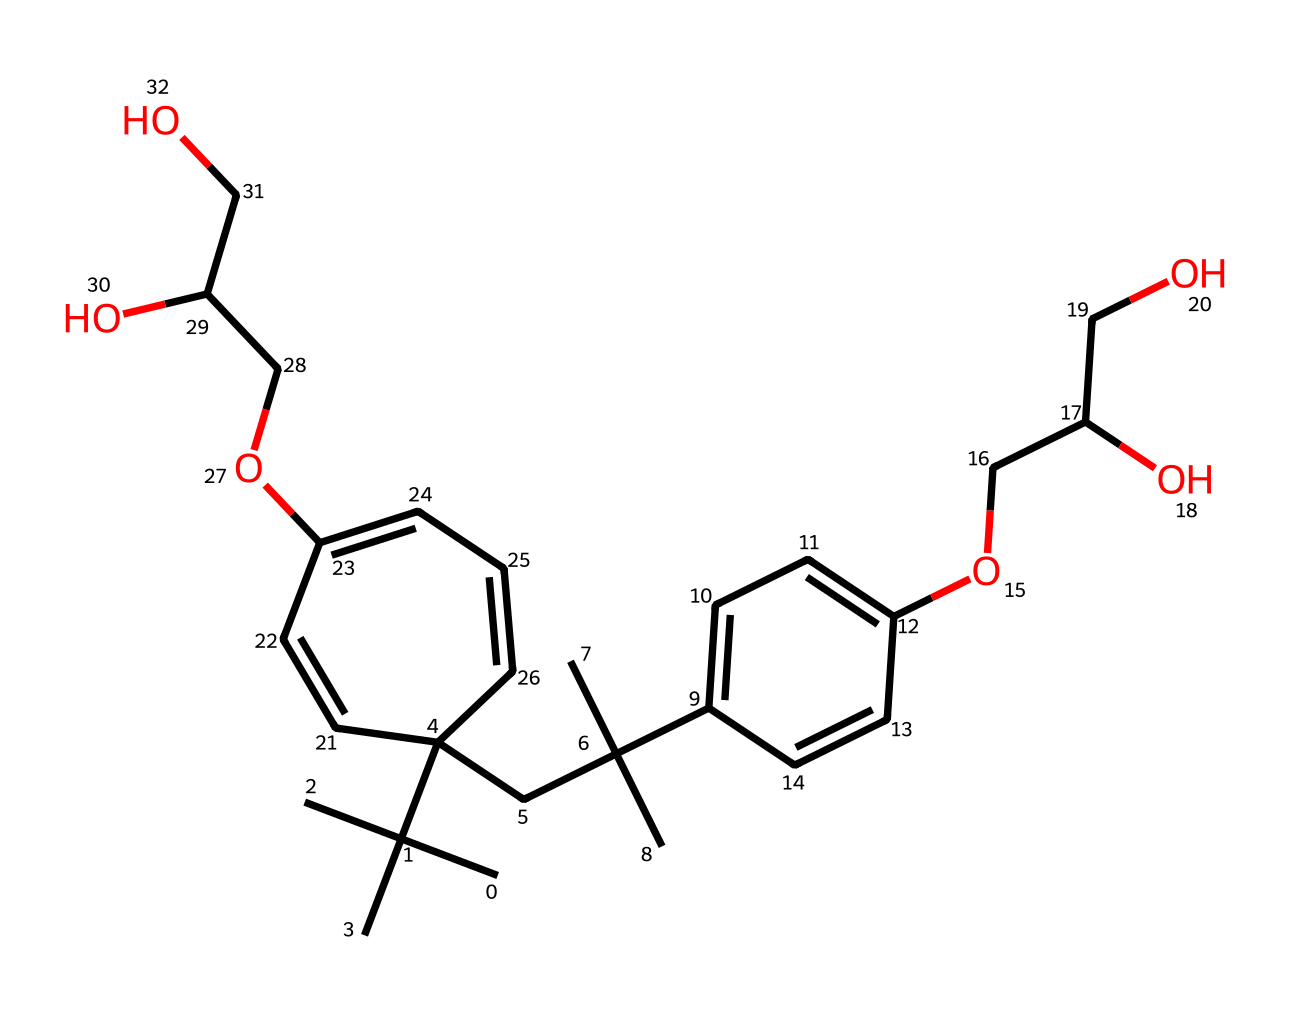What is the molecular formula of this compound? By analyzing the SMILES representation, we identify the carbon (C), hydrogen (H), and oxygen (O) atoms present. Counting the individual atoms gives us the formula C23H38O4.
Answer: C23H38O4 How many carbon atoms are present in the molecule? In the provided SMILES, we can see each ‘C’ represents a carbon atom. Counting the carbon atoms in the structure results in 23 carbons.
Answer: 23 What type of polymer is represented by this structure? The structure indicates that this compound is a type of silicone polymer due to the presence of repeat units connected by flexible links, characteristic of non-Newtonian fluids like silly putty.
Answer: silicone What properties of the molecule contribute to its non-Newtonian behavior? The molecular structure contains both flexible segments and rigid segments, allowing it to respond differently to stress; the soft segments flow under slow stress and the rigid segments maintain shape under rapid stress, typical in non-Newtonian fluids.
Answer: flexible and rigid Does this compound exhibit shear-thinning behavior? Yes, shear-thinning behavior is indicated if the chemical flows more easily under stress, which is a characteristic of the molecular interactions present in the structure.
Answer: yes What functional groups are present in this chemical? Upon examining the structure, we observe hydroxyl (-OH) groups, indicating the presence of alcohols which play a role in its physical properties.
Answer: hydroxyl What is the impact of the molecular flexibility on the performance of this fluid? The flexibility in molecular chains allows the material to deform under stress, absorbing energy and returning to its original state, which is crucial for applications requiring resilience and adaptability.
Answer: resilience 